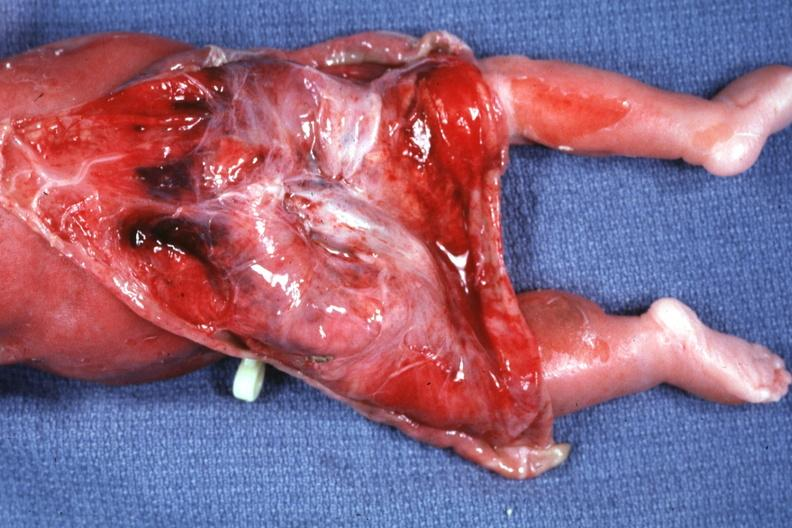what is skin over back a buttocks reflected?
Answer the question using a single word or phrase. To show large tumor mass 